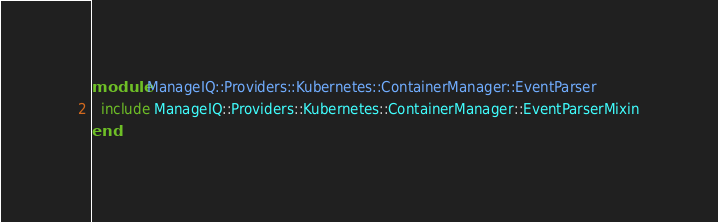Convert code to text. <code><loc_0><loc_0><loc_500><loc_500><_Ruby_>module ManageIQ::Providers::Kubernetes::ContainerManager::EventParser
  include ManageIQ::Providers::Kubernetes::ContainerManager::EventParserMixin
end
</code> 